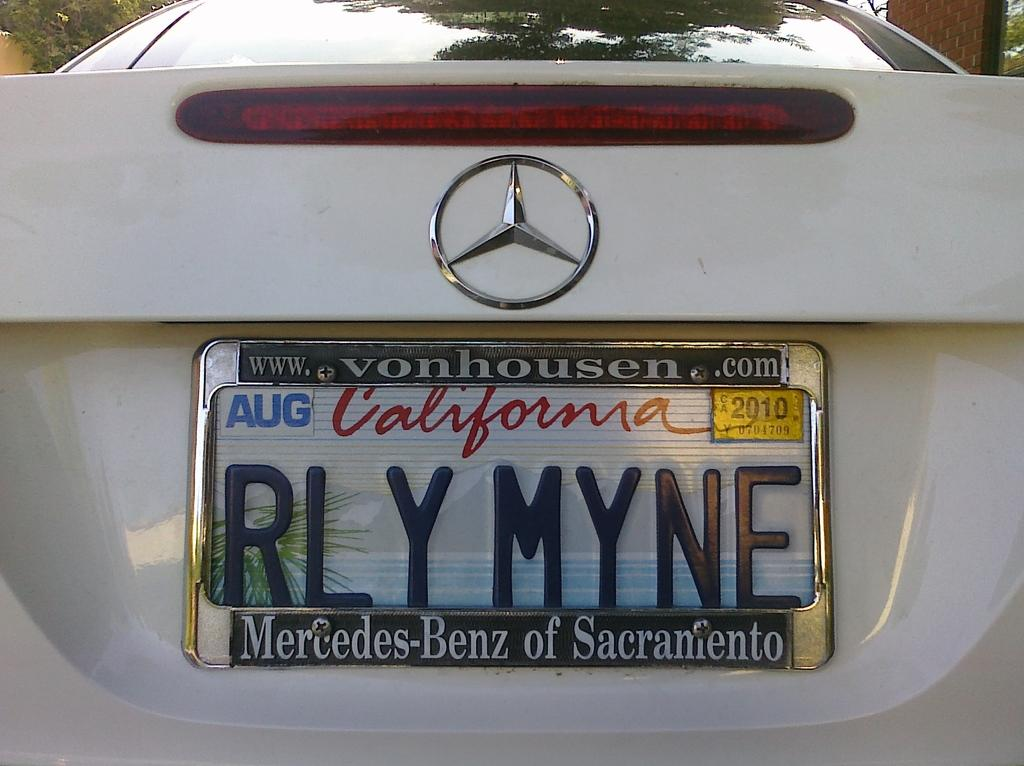<image>
Summarize the visual content of the image. The person that owns this Mercedez is happy that the car is really theirs. 